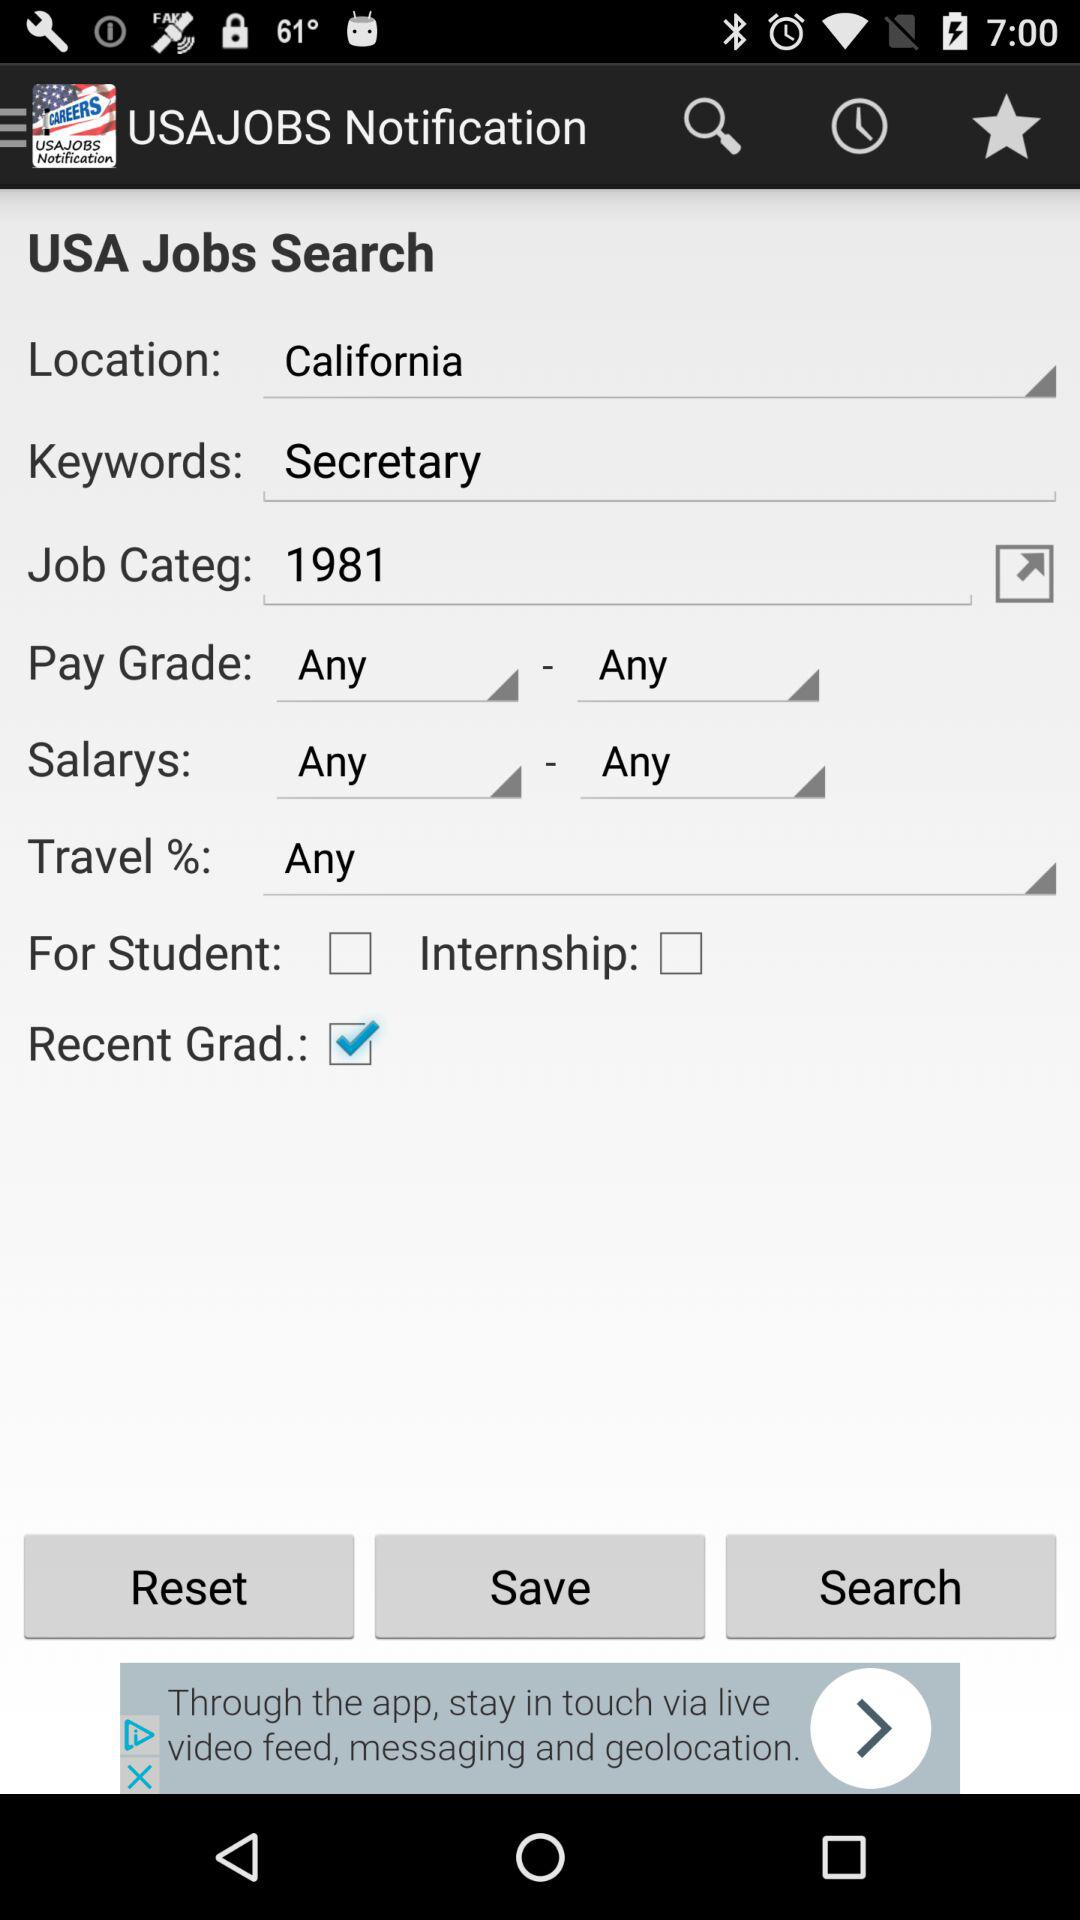What is the status of "Recent Grad."? The status is "on". 